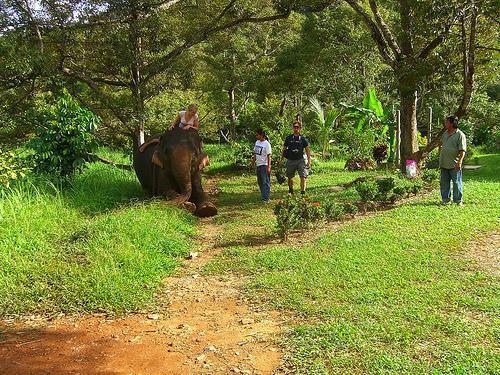How many elephants are there?
Give a very brief answer. 1. How many animals are in the picture?
Give a very brief answer. 1. How many people are in the picture?
Give a very brief answer. 4. How many pairs of pants are seen?
Give a very brief answer. 2. How many people are next to the animal?
Give a very brief answer. 2. 